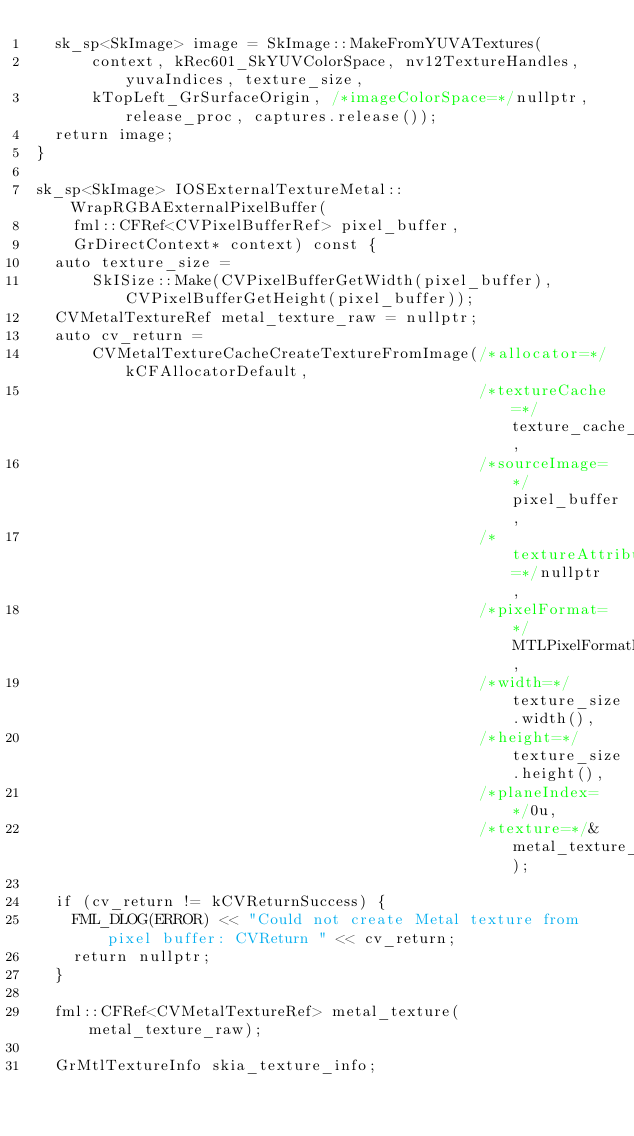Convert code to text. <code><loc_0><loc_0><loc_500><loc_500><_ObjectiveC_>  sk_sp<SkImage> image = SkImage::MakeFromYUVATextures(
      context, kRec601_SkYUVColorSpace, nv12TextureHandles, yuvaIndices, texture_size,
      kTopLeft_GrSurfaceOrigin, /*imageColorSpace=*/nullptr, release_proc, captures.release());
  return image;
}

sk_sp<SkImage> IOSExternalTextureMetal::WrapRGBAExternalPixelBuffer(
    fml::CFRef<CVPixelBufferRef> pixel_buffer,
    GrDirectContext* context) const {
  auto texture_size =
      SkISize::Make(CVPixelBufferGetWidth(pixel_buffer), CVPixelBufferGetHeight(pixel_buffer));
  CVMetalTextureRef metal_texture_raw = nullptr;
  auto cv_return =
      CVMetalTextureCacheCreateTextureFromImage(/*allocator=*/kCFAllocatorDefault,
                                                /*textureCache=*/texture_cache_,
                                                /*sourceImage=*/pixel_buffer,
                                                /*textureAttributes=*/nullptr,
                                                /*pixelFormat=*/MTLPixelFormatBGRA8Unorm,
                                                /*width=*/texture_size.width(),
                                                /*height=*/texture_size.height(),
                                                /*planeIndex=*/0u,
                                                /*texture=*/&metal_texture_raw);

  if (cv_return != kCVReturnSuccess) {
    FML_DLOG(ERROR) << "Could not create Metal texture from pixel buffer: CVReturn " << cv_return;
    return nullptr;
  }

  fml::CFRef<CVMetalTextureRef> metal_texture(metal_texture_raw);

  GrMtlTextureInfo skia_texture_info;</code> 